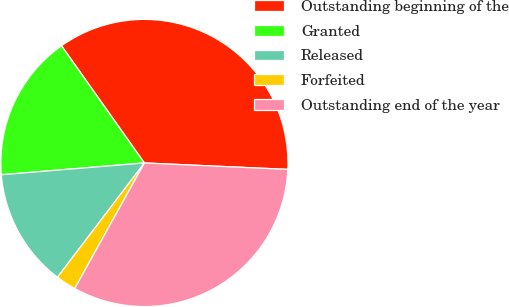Convert chart to OTSL. <chart><loc_0><loc_0><loc_500><loc_500><pie_chart><fcel>Outstanding beginning of the<fcel>Granted<fcel>Released<fcel>Forfeited<fcel>Outstanding end of the year<nl><fcel>35.51%<fcel>16.51%<fcel>13.34%<fcel>2.29%<fcel>32.34%<nl></chart> 